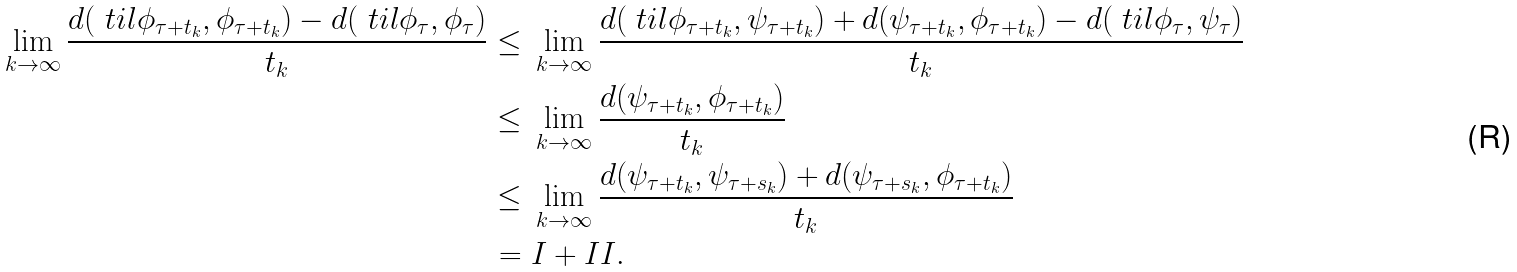Convert formula to latex. <formula><loc_0><loc_0><loc_500><loc_500>\lim _ { k \to \infty } \frac { d ( \ t i l { \phi } _ { \tau + t _ { k } } , { \phi } _ { \tau + t _ { k } } ) - d ( \ t i l { \phi } _ { \tau } , \phi _ { \tau } ) } { t _ { k } } \leq & \ \lim _ { k \to \infty } \frac { d ( \ t i l { \phi } _ { \tau + t _ { k } } , \psi _ { \tau + t _ { k } } ) + d ( \psi _ { \tau + t _ { k } } , { \phi } _ { \tau + t _ { k } } ) - d ( \ t i l { \phi } _ { \tau } , \psi _ { \tau } ) } { t _ { k } } \\ \leq & \ \lim _ { k \to \infty } \frac { d ( \psi _ { \tau + t _ { k } } , { \phi } _ { \tau + t _ { k } } ) } { t _ { k } } \\ \leq & \ \lim _ { k \to \infty } \frac { d ( \psi _ { \tau + t _ { k } } , \psi _ { \tau + s _ { k } } ) + d ( \psi _ { \tau + s _ { k } } , \phi _ { \tau + t _ { k } } ) } { t _ { k } } \\ = & \ I + I I .</formula> 